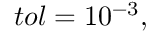Convert formula to latex. <formula><loc_0><loc_0><loc_500><loc_500>t o l = 1 0 ^ { - 3 } ,</formula> 